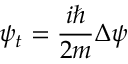Convert formula to latex. <formula><loc_0><loc_0><loc_500><loc_500>\psi _ { t } = { \frac { i } { 2 m } } \Delta \psi</formula> 